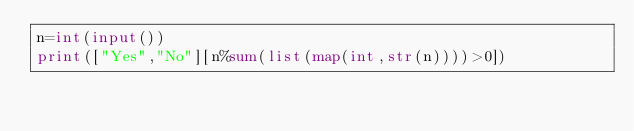Convert code to text. <code><loc_0><loc_0><loc_500><loc_500><_Python_>n=int(input())
print(["Yes","No"][n%sum(list(map(int,str(n))))>0])</code> 